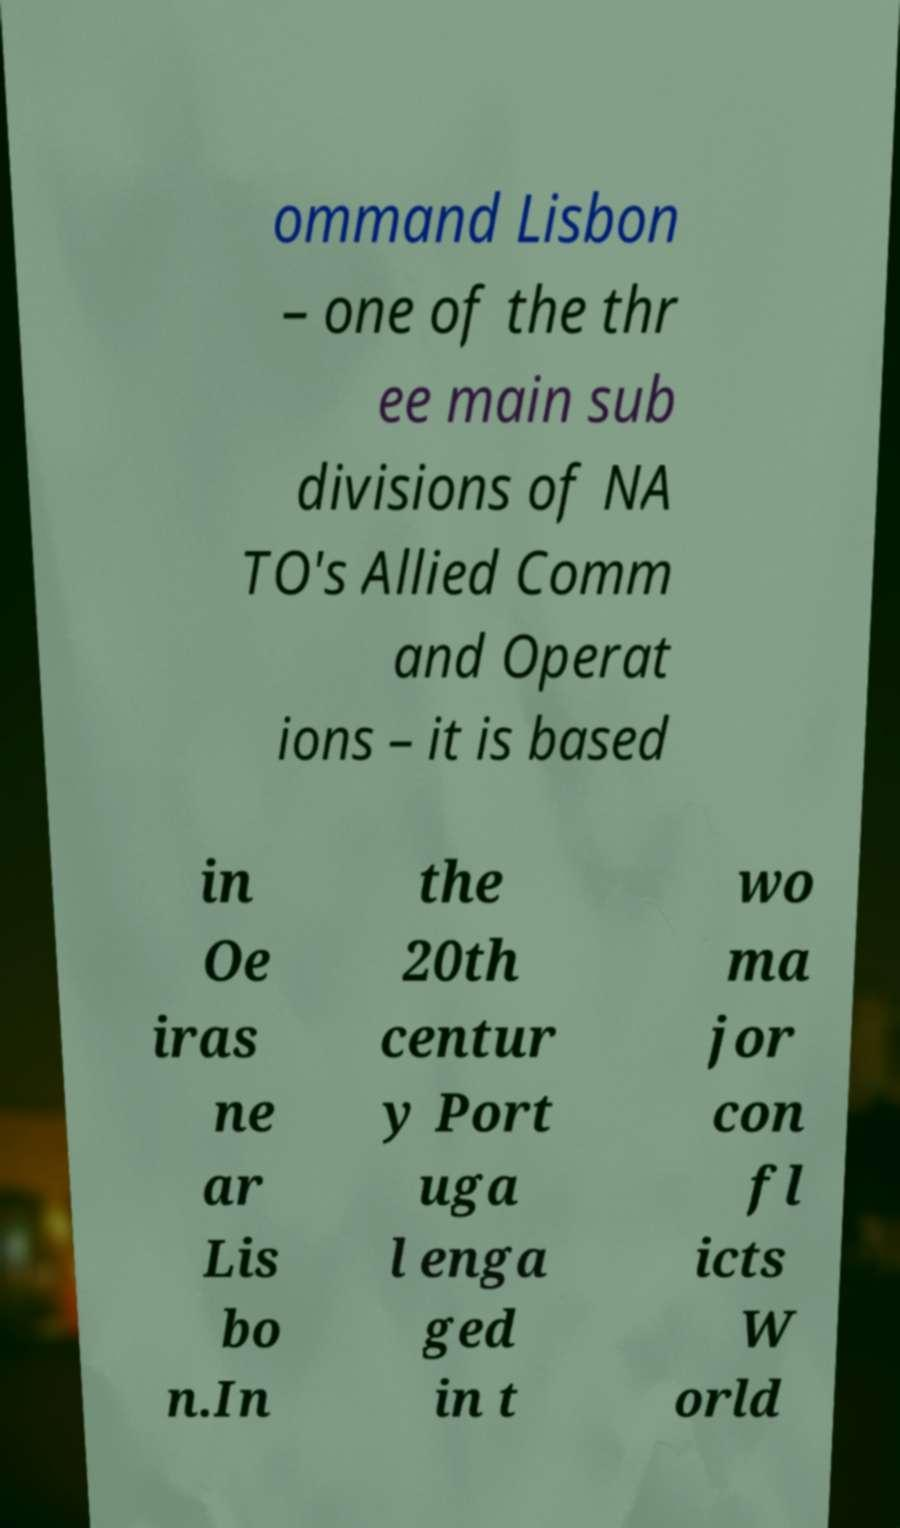What messages or text are displayed in this image? I need them in a readable, typed format. ommand Lisbon – one of the thr ee main sub divisions of NA TO's Allied Comm and Operat ions – it is based in Oe iras ne ar Lis bo n.In the 20th centur y Port uga l enga ged in t wo ma jor con fl icts W orld 